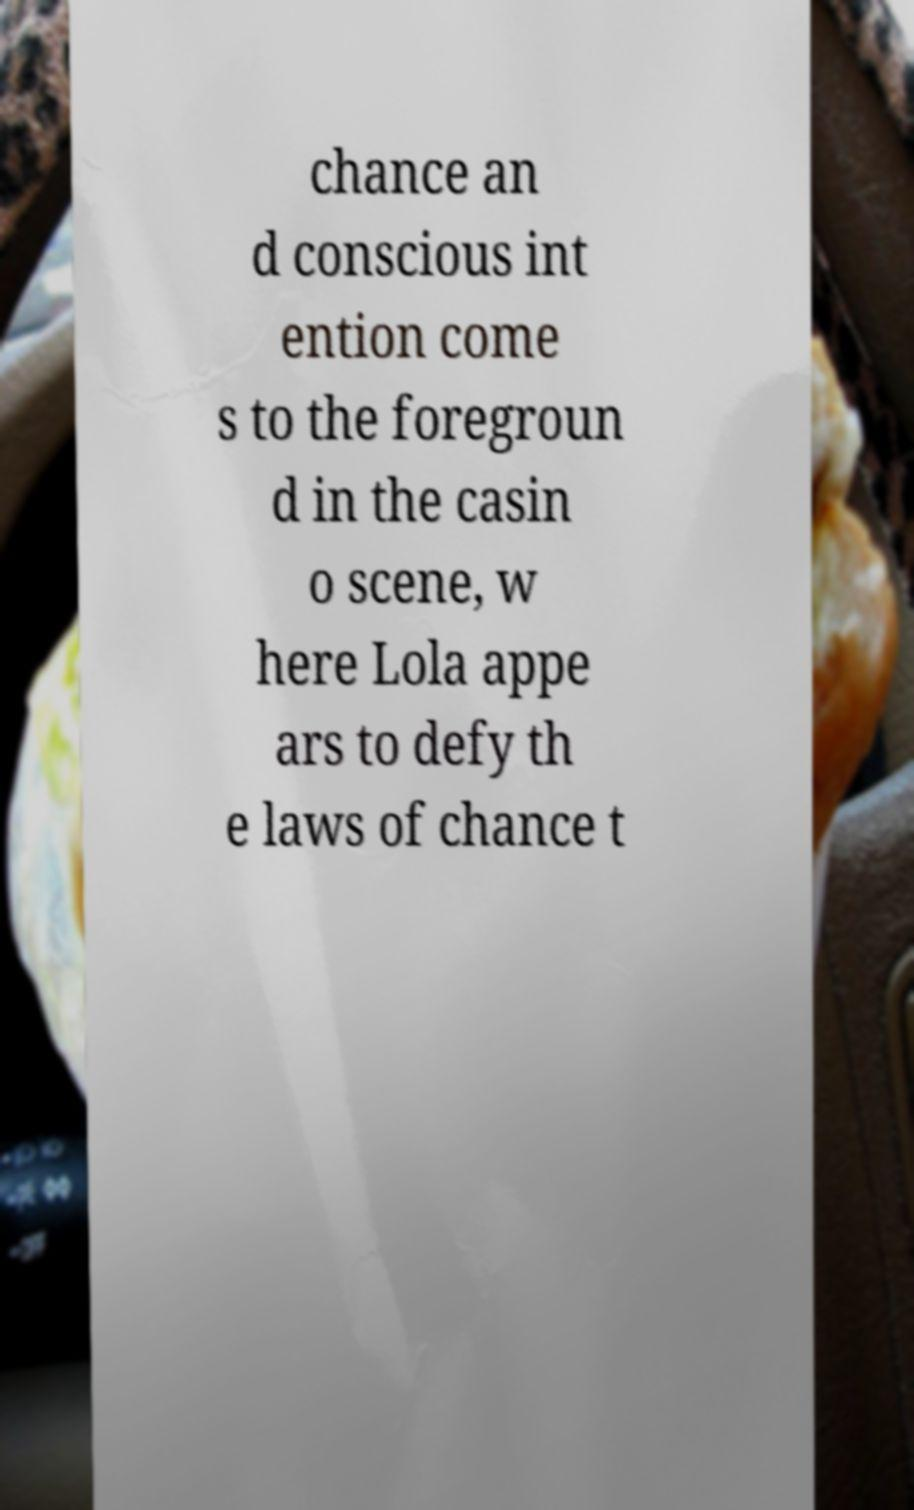Could you extract and type out the text from this image? chance an d conscious int ention come s to the foregroun d in the casin o scene, w here Lola appe ars to defy th e laws of chance t 